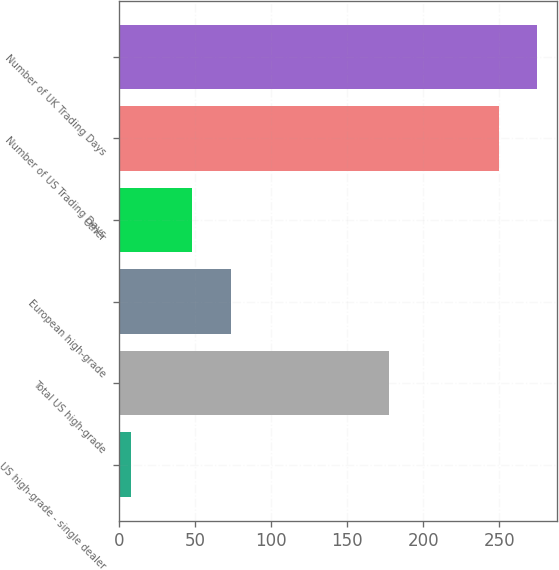Convert chart. <chart><loc_0><loc_0><loc_500><loc_500><bar_chart><fcel>US high-grade - single dealer<fcel>Total US high-grade<fcel>European high-grade<fcel>Other<fcel>Number of US Trading Days<fcel>Number of UK Trading Days<nl><fcel>7.5<fcel>177.6<fcel>73.4<fcel>48.2<fcel>250<fcel>274.55<nl></chart> 